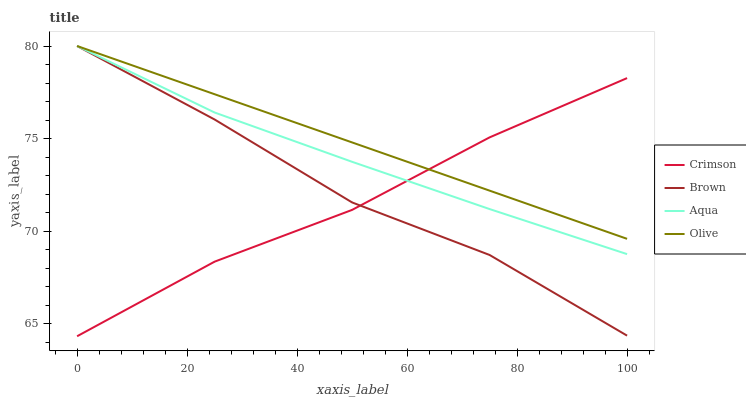Does Brown have the minimum area under the curve?
Answer yes or no. No. Does Brown have the maximum area under the curve?
Answer yes or no. No. Is Aqua the smoothest?
Answer yes or no. No. Is Aqua the roughest?
Answer yes or no. No. Does Brown have the lowest value?
Answer yes or no. No. 